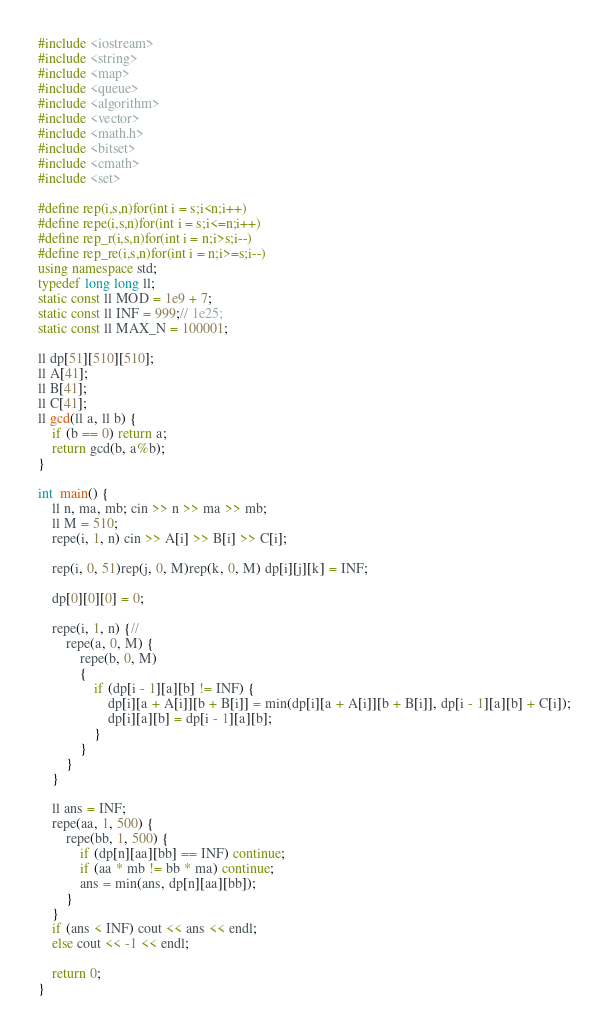<code> <loc_0><loc_0><loc_500><loc_500><_C++_>#include <iostream>
#include <string>
#include <map>
#include <queue>
#include <algorithm>
#include <vector>
#include <math.h>
#include <bitset>
#include <cmath>
#include <set>

#define rep(i,s,n)for(int i = s;i<n;i++)
#define repe(i,s,n)for(int i = s;i<=n;i++)
#define rep_r(i,s,n)for(int i = n;i>s;i--)
#define rep_re(i,s,n)for(int i = n;i>=s;i--)
using namespace std;
typedef long long ll;
static const ll MOD = 1e9 + 7;
static const ll INF = 999;// 1e25;
static const ll MAX_N = 100001;

ll dp[51][510][510];
ll A[41];
ll B[41];
ll C[41];
ll gcd(ll a, ll b) {
	if (b == 0) return a;
	return gcd(b, a%b);
}

int  main() {
	ll n, ma, mb; cin >> n >> ma >> mb;
	ll M = 510;
	repe(i, 1, n) cin >> A[i] >> B[i] >> C[i];

	rep(i, 0, 51)rep(j, 0, M)rep(k, 0, M) dp[i][j][k] = INF;

	dp[0][0][0] = 0;

	repe(i, 1, n) {//
		repe(a, 0, M) {
			repe(b, 0, M)
			{
				if (dp[i - 1][a][b] != INF) {
					dp[i][a + A[i]][b + B[i]] = min(dp[i][a + A[i]][b + B[i]], dp[i - 1][a][b] + C[i]);
					dp[i][a][b] = dp[i - 1][a][b];
				}
			}
		}
	}

	ll ans = INF;
	repe(aa, 1, 500) {
		repe(bb, 1, 500) {
			if (dp[n][aa][bb] == INF) continue;
			if (aa * mb != bb * ma) continue;
			ans = min(ans, dp[n][aa][bb]);
		}
	}
	if (ans < INF) cout << ans << endl;
	else cout << -1 << endl;

	return 0;
}</code> 